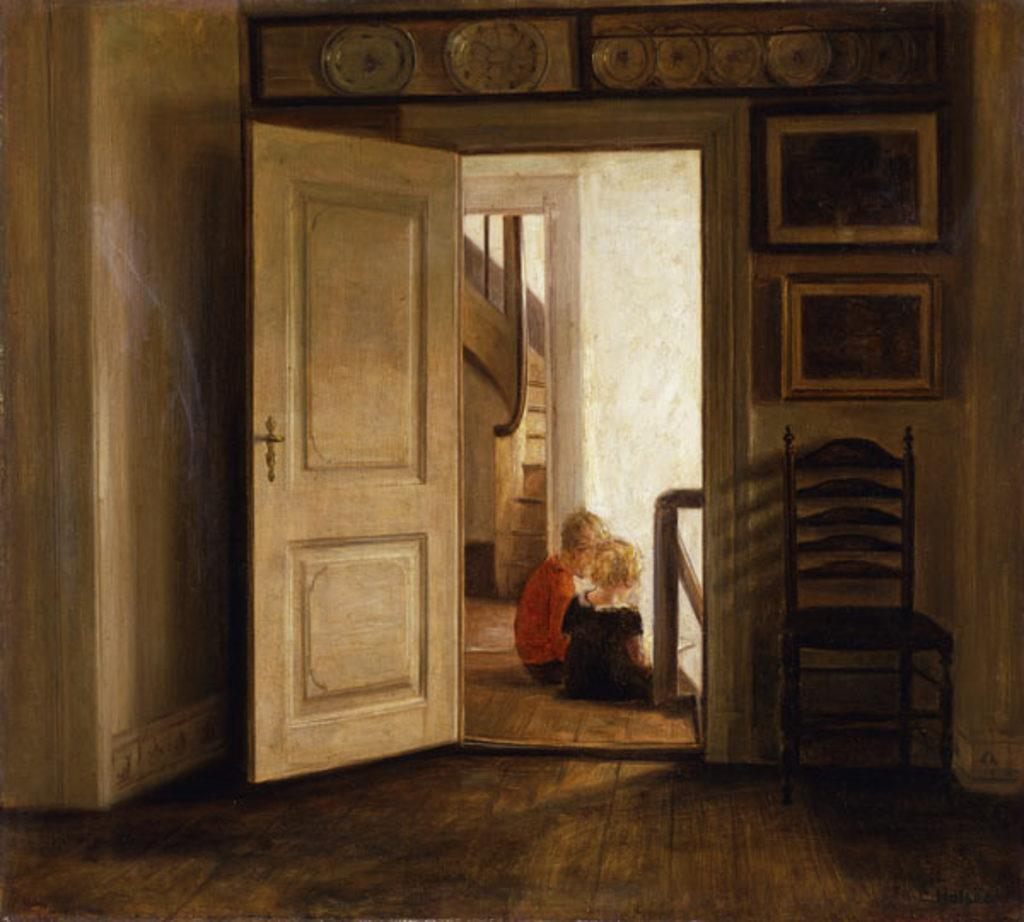What is the main subject of the image? There is a painting in the image. What type of furniture is present in the image? There is a chair in the image. What part of the room can be seen in the image? The floor is visible in the image. What is hanging on the wall in the image? There are frames on the wall in the image. What objects are on the table in the image? There are plates in the image. Who is present in the image? Two kids are sitting in the image. What type of popcorn is being served on the sticks in the image? There is no popcorn or sticks present in the image. 